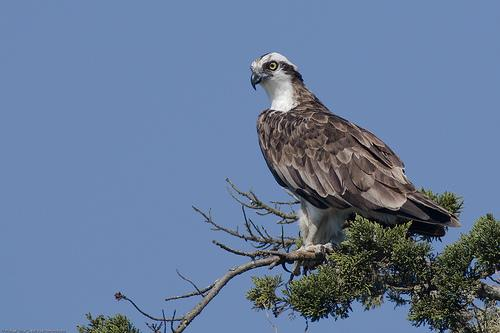Is the sky in the image cloudy or clear? The sky is clear and blue. Mention three features of the bird in the image. The bird has a white head, a grey tail, and a black beak. Can you describe the bird's beak and what color it is? The bird has a hooked beak, and it is black. What color are the bird's legs and the branch it is standing on? The bird's legs are white, and the branch is light grey. What part of the bird seems to be covered by leaves? Leaves seem to be covering the bird's wing. How many tail feathers can be observed in the bird? Some long tail feathers are visible, though the exact number cannot be determined from the specifications. What color are the bird's eyes in the image? The bird's eyes are glowing yellow. What is the condition of the branches in the image? There are a few bare branches and some branches with green needles. Briefly describe the scene in the image. The image showcases a large bird of prey with a white head and yellow eyes, standing on a branch with green needles, against a clear blue sky. What kind of tree is the bird perched on? The bird is perched on a tree with thin evergreen branches and green needles. From the image, describe the environment surrounding the bird. A clear blue sky, a branch with green leaves and no leaves sections How would you describe the foliage on the branch where the bird is perched? Green needles and short leaves How would you describe the appearance of the bird's tail feathers? Grey and long What is the color of the bird's legs in the image? White Are there any orange branches in the image? The branches are described as light grey and having green needles or no leaves, but there's no mention of them being orange. Asking about orange branches is misleading and incorrect. Analyze the image and explain the relationship between the bird and its surrounding environment. The bird is perched on a branch, with green leaves and a clear blue sky background. Describe the bird's tail using details from the image. Grey, long tail feathers Identify and describe the bird's head features in the image. White head with a black hooked beak and a yellow eye Examine the image closely and describe the appearance of the bird's foot. White legs with a black claw What is the bird doing in the image? Looking off to the side Create a vivid description of the bird and its environment, combining details from the image. A majestic bird of prey with a white head, yellow eyes, and black hooked beak perches on a branch, surrounded by green leaves and a vibrant blue sky. Explain the overall coloring of the bird in the image. White head, grey breast, grey tail, and white legs Describe the appearance of the branch the bird is perched on. Light grey with green leaves and no leaves sections Does the bird have a square-shaped eye? No, it's not mentioned in the image. Choose the correct description of the bird's beak from the following: A) Flat and orange, B) Hooked and black, C) Short and grey, D) Long and brown. Hooked and black Describe the appearance of the sky in the image. Clear blue and daytime What color is the eye of the bird in the image? Yellow Examine the image and state whether the bird is standing or flying. Standing on a branch The bird in the image has a unique pattern on its breast. Which of the following best describes it: A) Striped, B) Spotted, C) Solid color, D) Various patterns. Various patterns Identify the type of bird in the image and give a brief description of its details. Bird of prey with a white head, yellow eyes, and a hooked black beak 